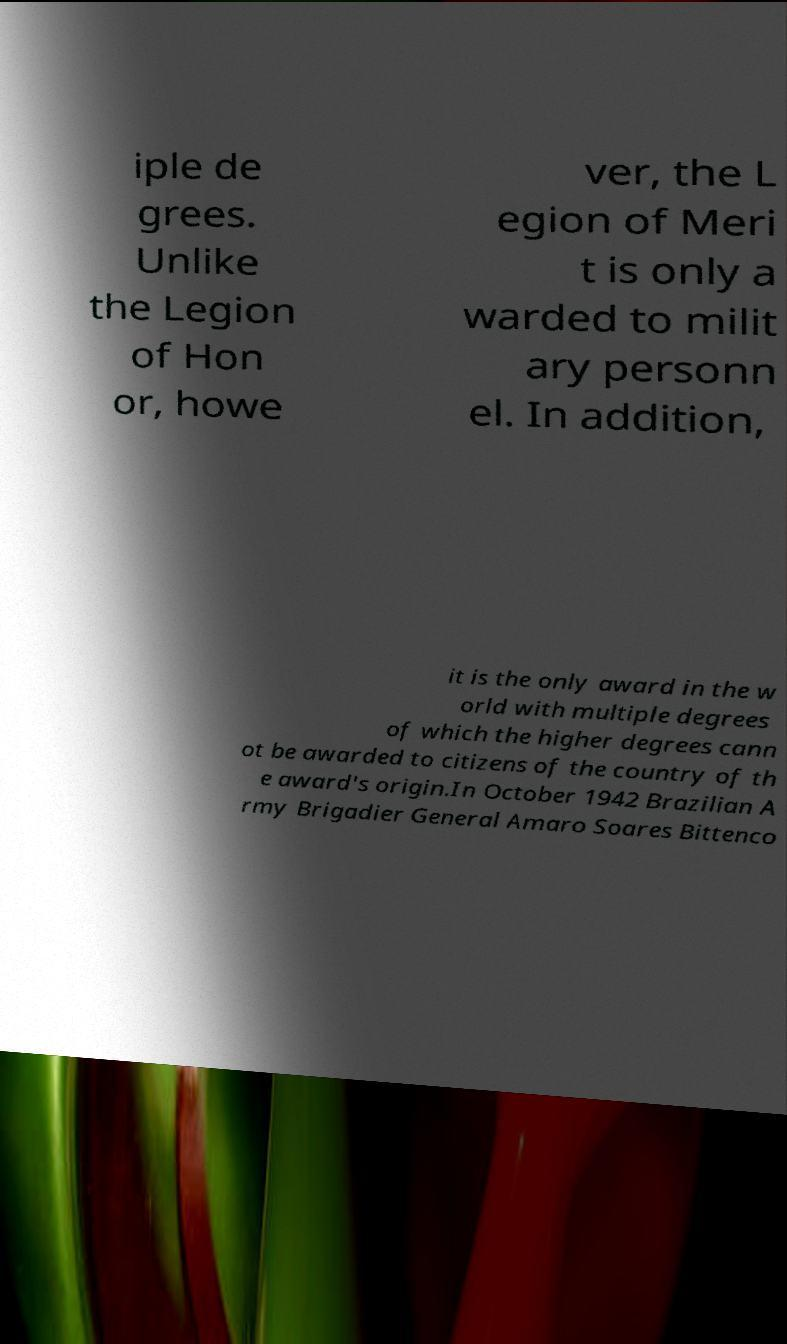Please identify and transcribe the text found in this image. iple de grees. Unlike the Legion of Hon or, howe ver, the L egion of Meri t is only a warded to milit ary personn el. In addition, it is the only award in the w orld with multiple degrees of which the higher degrees cann ot be awarded to citizens of the country of th e award's origin.In October 1942 Brazilian A rmy Brigadier General Amaro Soares Bittenco 